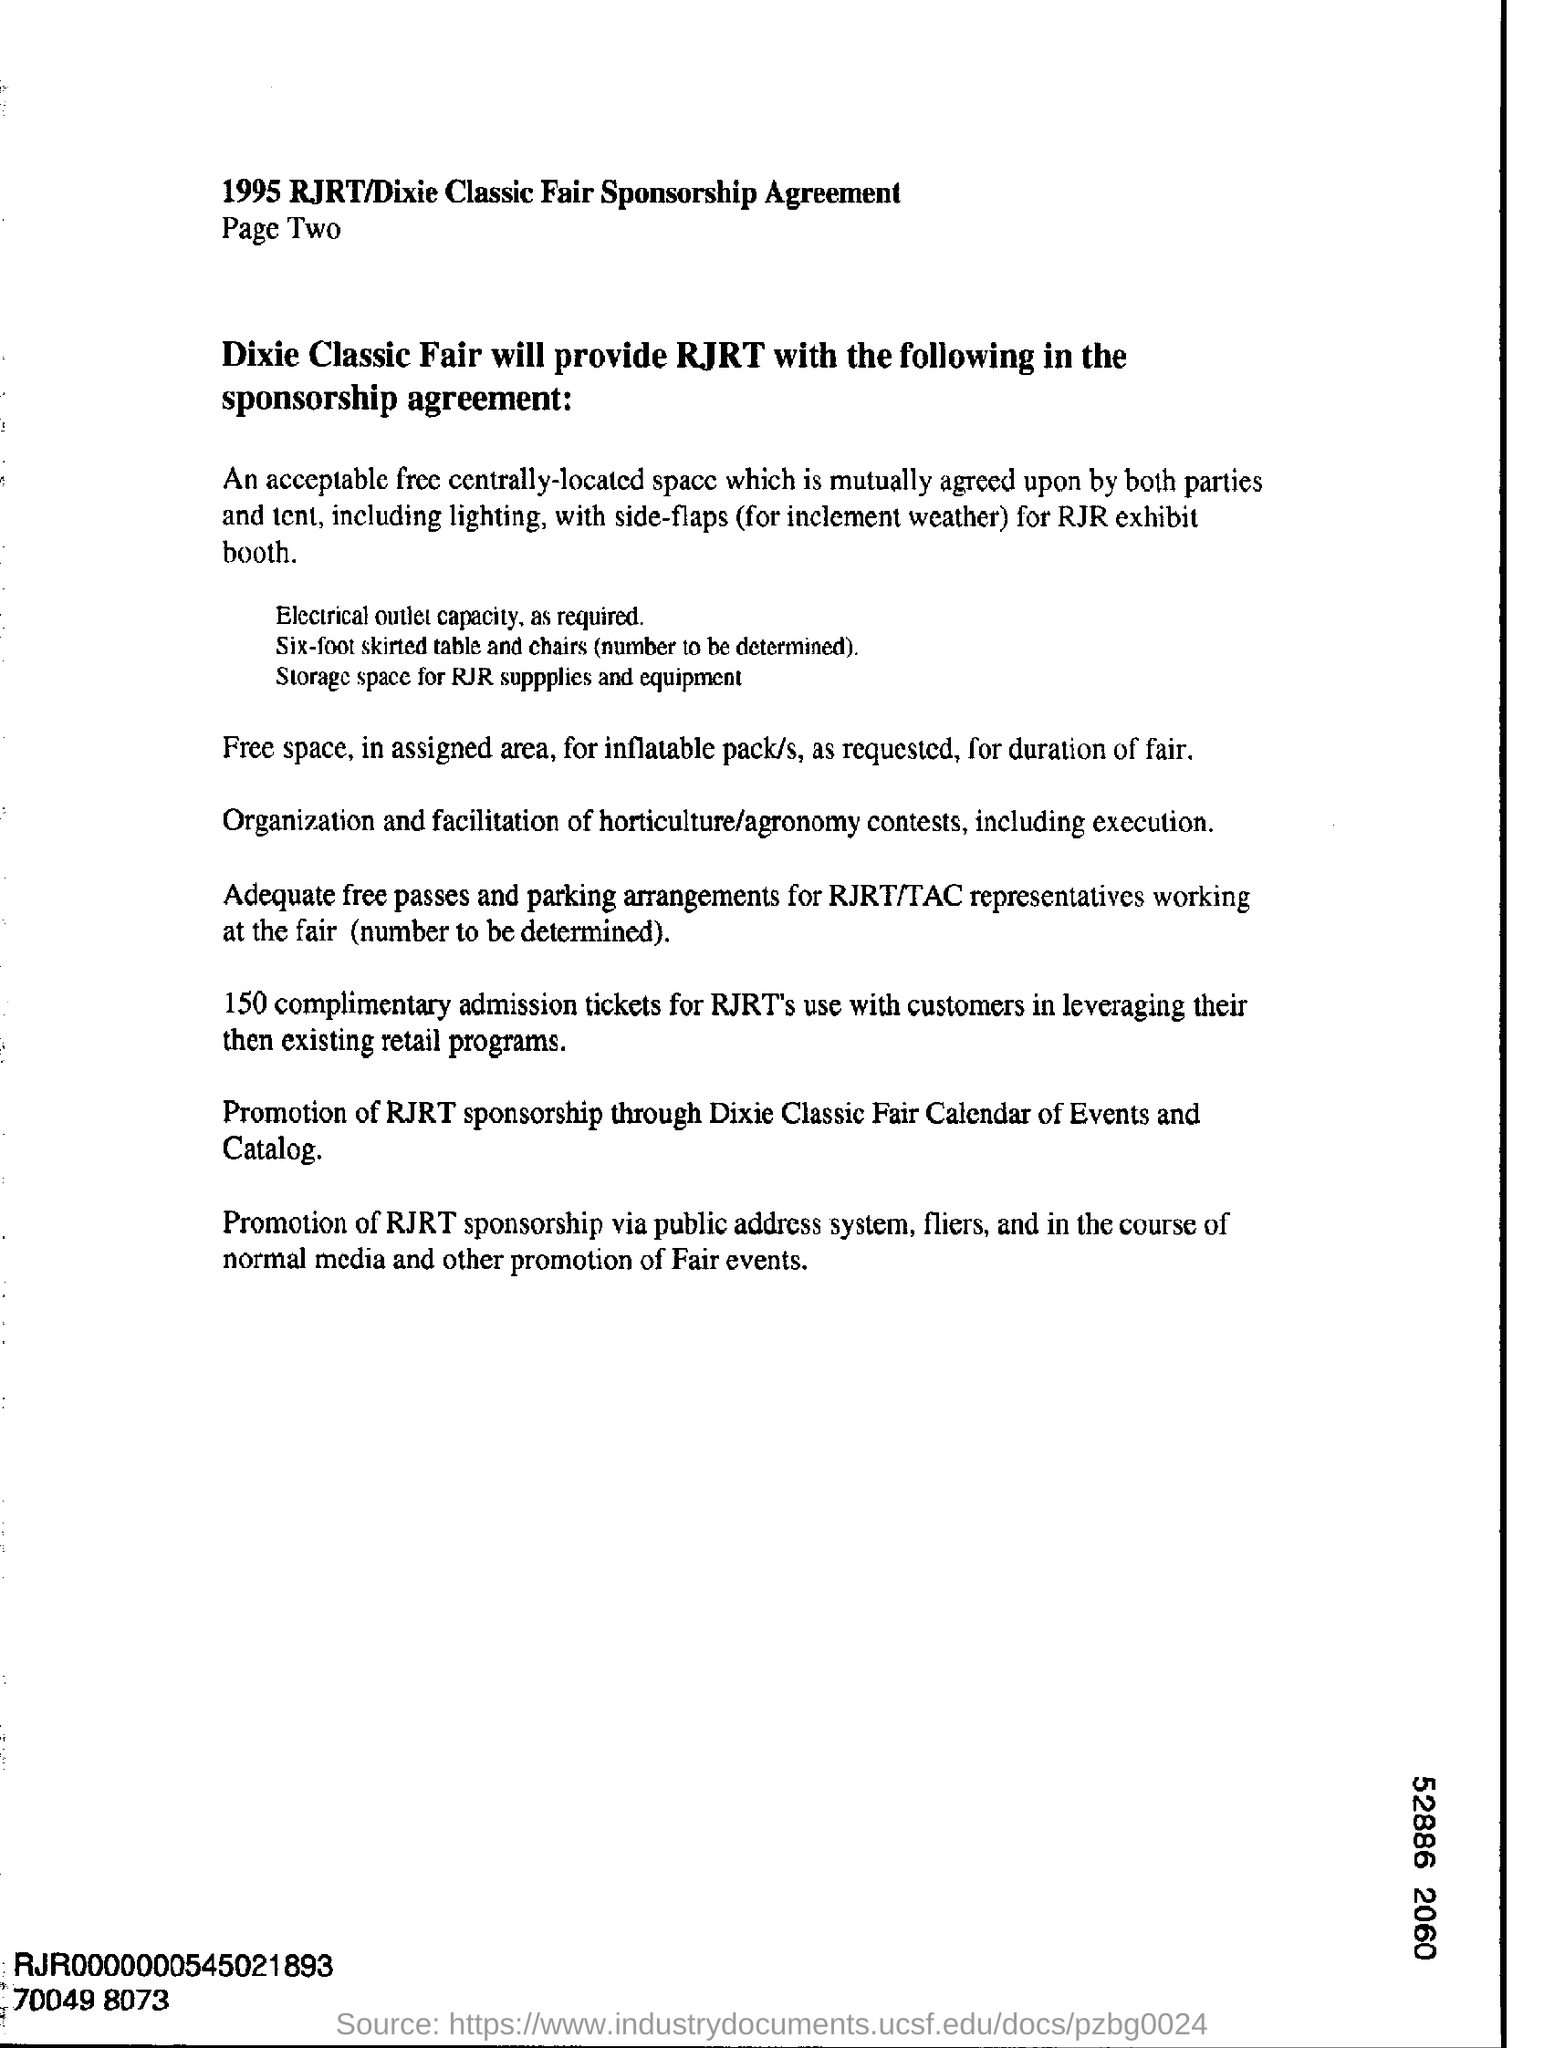What is digit shown at the bottom right corner?
Give a very brief answer. 52886 2060. 